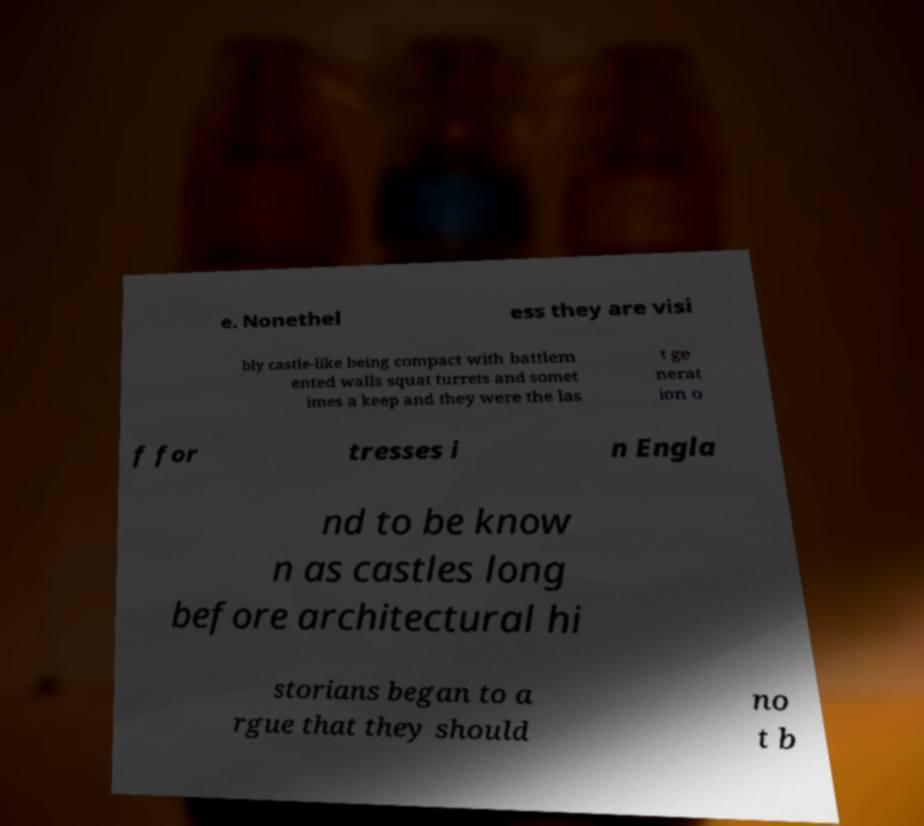There's text embedded in this image that I need extracted. Can you transcribe it verbatim? e. Nonethel ess they are visi bly castle-like being compact with battlem ented walls squat turrets and somet imes a keep and they were the las t ge nerat ion o f for tresses i n Engla nd to be know n as castles long before architectural hi storians began to a rgue that they should no t b 